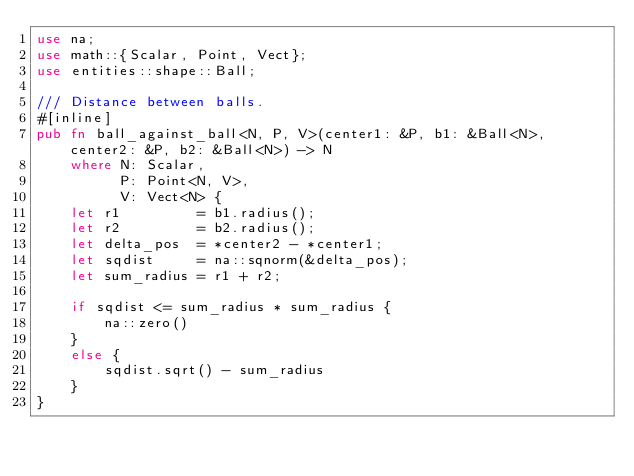<code> <loc_0><loc_0><loc_500><loc_500><_Rust_>use na;
use math::{Scalar, Point, Vect};
use entities::shape::Ball;

/// Distance between balls.
#[inline]
pub fn ball_against_ball<N, P, V>(center1: &P, b1: &Ball<N>, center2: &P, b2: &Ball<N>) -> N
    where N: Scalar,
          P: Point<N, V>,
          V: Vect<N> {
    let r1         = b1.radius();
    let r2         = b2.radius();
    let delta_pos  = *center2 - *center1;
    let sqdist     = na::sqnorm(&delta_pos);
    let sum_radius = r1 + r2;

    if sqdist <= sum_radius * sum_radius {
        na::zero()
    }
    else {
        sqdist.sqrt() - sum_radius
    }
}
</code> 